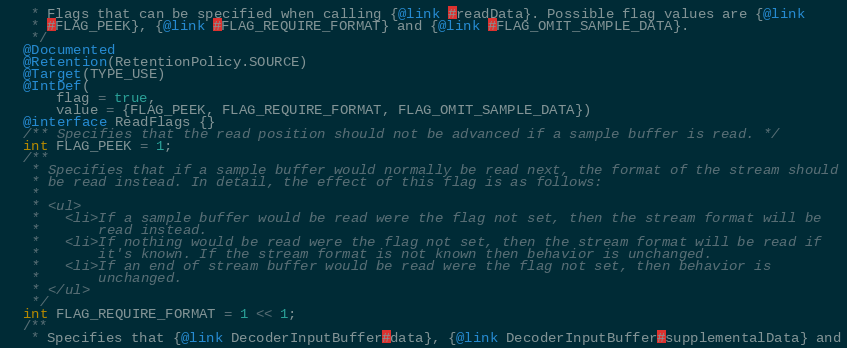Convert code to text. <code><loc_0><loc_0><loc_500><loc_500><_Java_>   * Flags that can be specified when calling {@link #readData}. Possible flag values are {@link
   * #FLAG_PEEK}, {@link #FLAG_REQUIRE_FORMAT} and {@link #FLAG_OMIT_SAMPLE_DATA}.
   */
  @Documented
  @Retention(RetentionPolicy.SOURCE)
  @Target(TYPE_USE)
  @IntDef(
      flag = true,
      value = {FLAG_PEEK, FLAG_REQUIRE_FORMAT, FLAG_OMIT_SAMPLE_DATA})
  @interface ReadFlags {}
  /** Specifies that the read position should not be advanced if a sample buffer is read. */
  int FLAG_PEEK = 1;
  /**
   * Specifies that if a sample buffer would normally be read next, the format of the stream should
   * be read instead. In detail, the effect of this flag is as follows:
   *
   * <ul>
   *   <li>If a sample buffer would be read were the flag not set, then the stream format will be
   *       read instead.
   *   <li>If nothing would be read were the flag not set, then the stream format will be read if
   *       it's known. If the stream format is not known then behavior is unchanged.
   *   <li>If an end of stream buffer would be read were the flag not set, then behavior is
   *       unchanged.
   * </ul>
   */
  int FLAG_REQUIRE_FORMAT = 1 << 1;
  /**
   * Specifies that {@link DecoderInputBuffer#data}, {@link DecoderInputBuffer#supplementalData} and</code> 